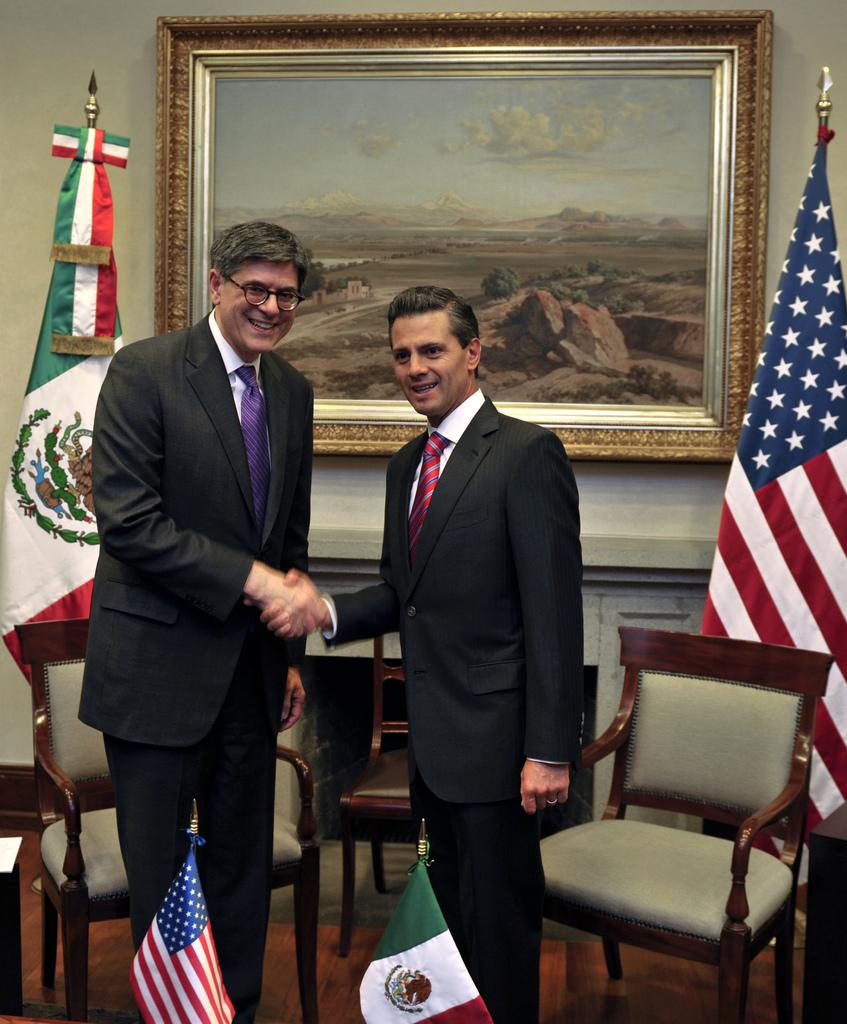How many people are in the image? There are two men in the image. What are the men doing in the image? The men are greeting each other. Can you describe any furniture in the image? There is a chair in the image. What else can be seen in the image besides the men and the chair? There is a flag and a wall frame in the image. What type of straw is being used as a prop in the image? There is no straw present in the image. 